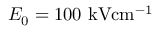Convert formula to latex. <formula><loc_0><loc_0><loc_500><loc_500>E _ { 0 } = 1 0 0 { k V c m ^ { - 1 } }</formula> 